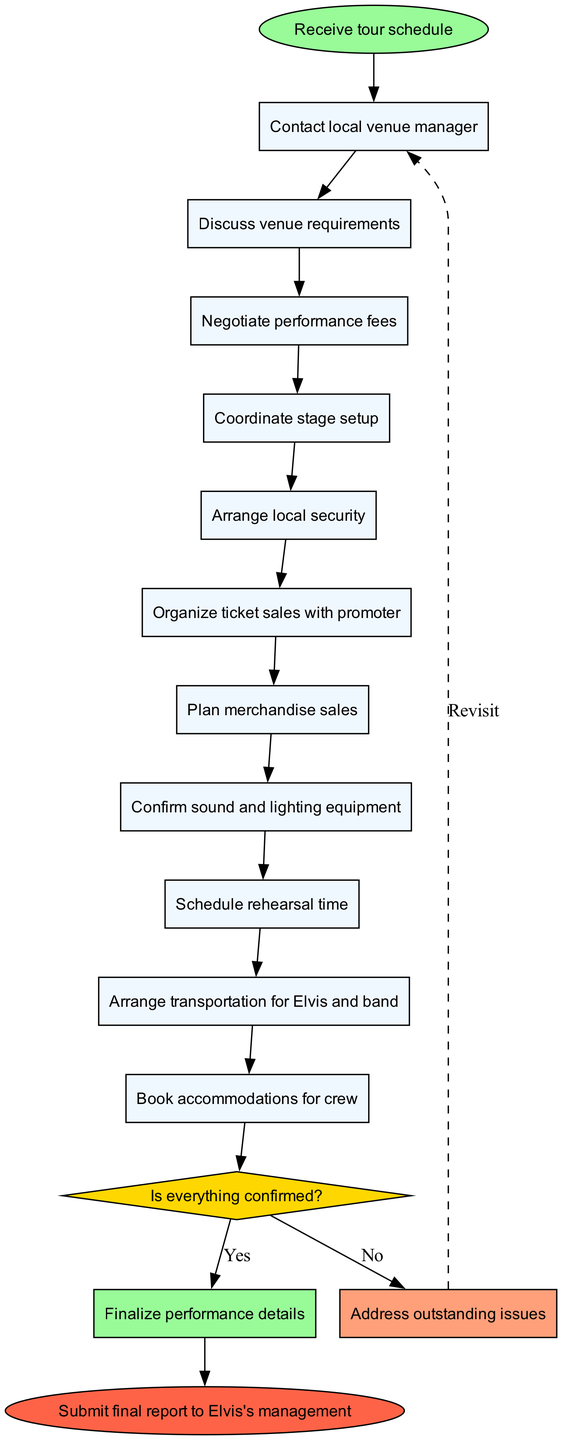What is the first step in the coordination process? The first step according to the diagram is "Contact local venue manager." It is connected directly to the starting point, indicating it is the initial action taken after receiving the tour schedule.
Answer: Contact local venue manager How many total steps are outlined in the coordination process? The diagram outlines a total of 11 steps, including the final decision and actions leading up to the conclusion. This can be counted by reviewing each step node listed in the diagram before the decision point.
Answer: 11 What is the final action if everything is confirmed? If everything is confirmed, the action specified in the diagram is to "Finalize performance details." This outcome occurs directly after the yes branch from the decision node.
Answer: Finalize performance details Which step comes after negotiating performance fees? The step that comes after negotiating performance fees is "Coordinate stage setup." This is identified by the sequential flow from one step to the next in the diagram.
Answer: Coordinate stage setup What happens if not all issues are addressed? If there are outstanding issues, the next action is to "Address outstanding issues." This flow leads back to the decision-making point, indicating that unresolved matters need to be revisited.
Answer: Address outstanding issues What shape represents the decision-making point in the diagram? The decision-making point is represented by a diamond shape, which is a standard representation in flow charts for decision nodes indicating a choice between options.
Answer: Diamond After addressing outstanding issues, which step is revisited? The step that is revisited after addressing outstanding issues is "Contact local venue manager." This is connected back to the process from the no branch of the decision node, indicating a return to a prior step.
Answer: Contact local venue manager What is the penultimate step before submitting the final report? The penultimate step before submitting the final report is "Book accommodations for crew." This step directly precedes the end of the process and is part of the final preparations before the report submission.
Answer: Book accommodations for crew 